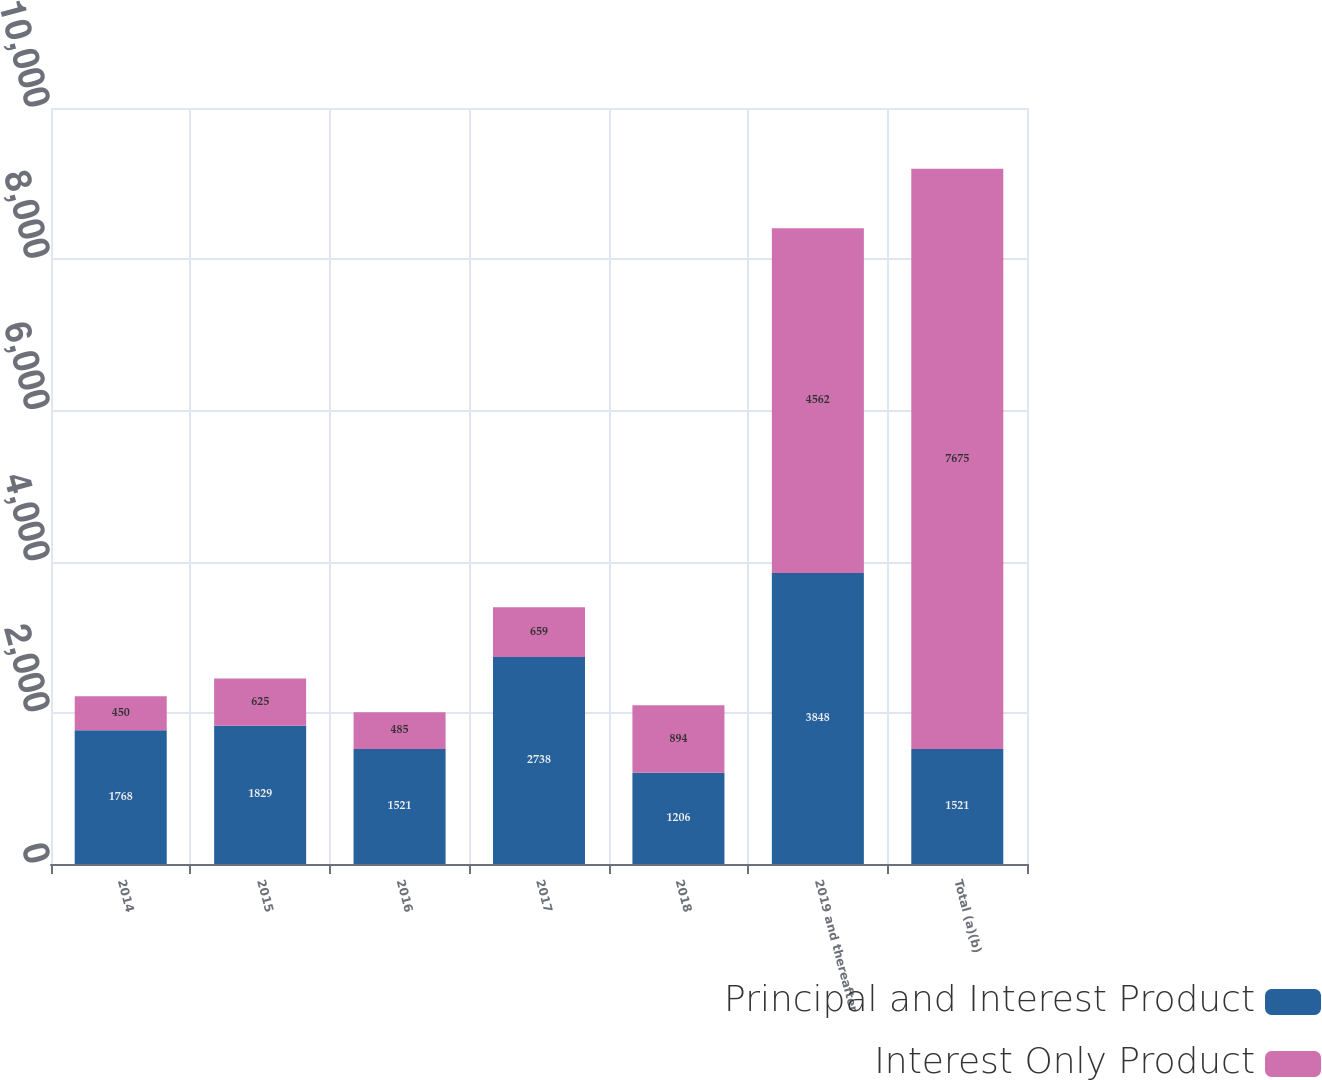Convert chart to OTSL. <chart><loc_0><loc_0><loc_500><loc_500><stacked_bar_chart><ecel><fcel>2014<fcel>2015<fcel>2016<fcel>2017<fcel>2018<fcel>2019 and thereafter<fcel>Total (a)(b)<nl><fcel>Principal and Interest Product<fcel>1768<fcel>1829<fcel>1521<fcel>2738<fcel>1206<fcel>3848<fcel>1521<nl><fcel>Interest Only Product<fcel>450<fcel>625<fcel>485<fcel>659<fcel>894<fcel>4562<fcel>7675<nl></chart> 